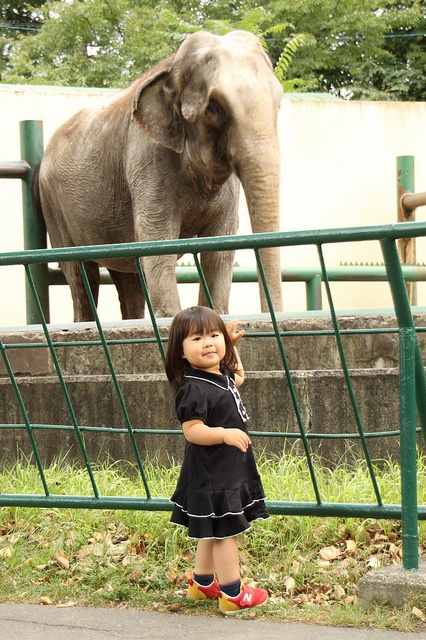Describe the objects in this image and their specific colors. I can see elephant in darkgreen, ivory, black, gray, and tan tones and people in darkgreen, black, gray, and tan tones in this image. 